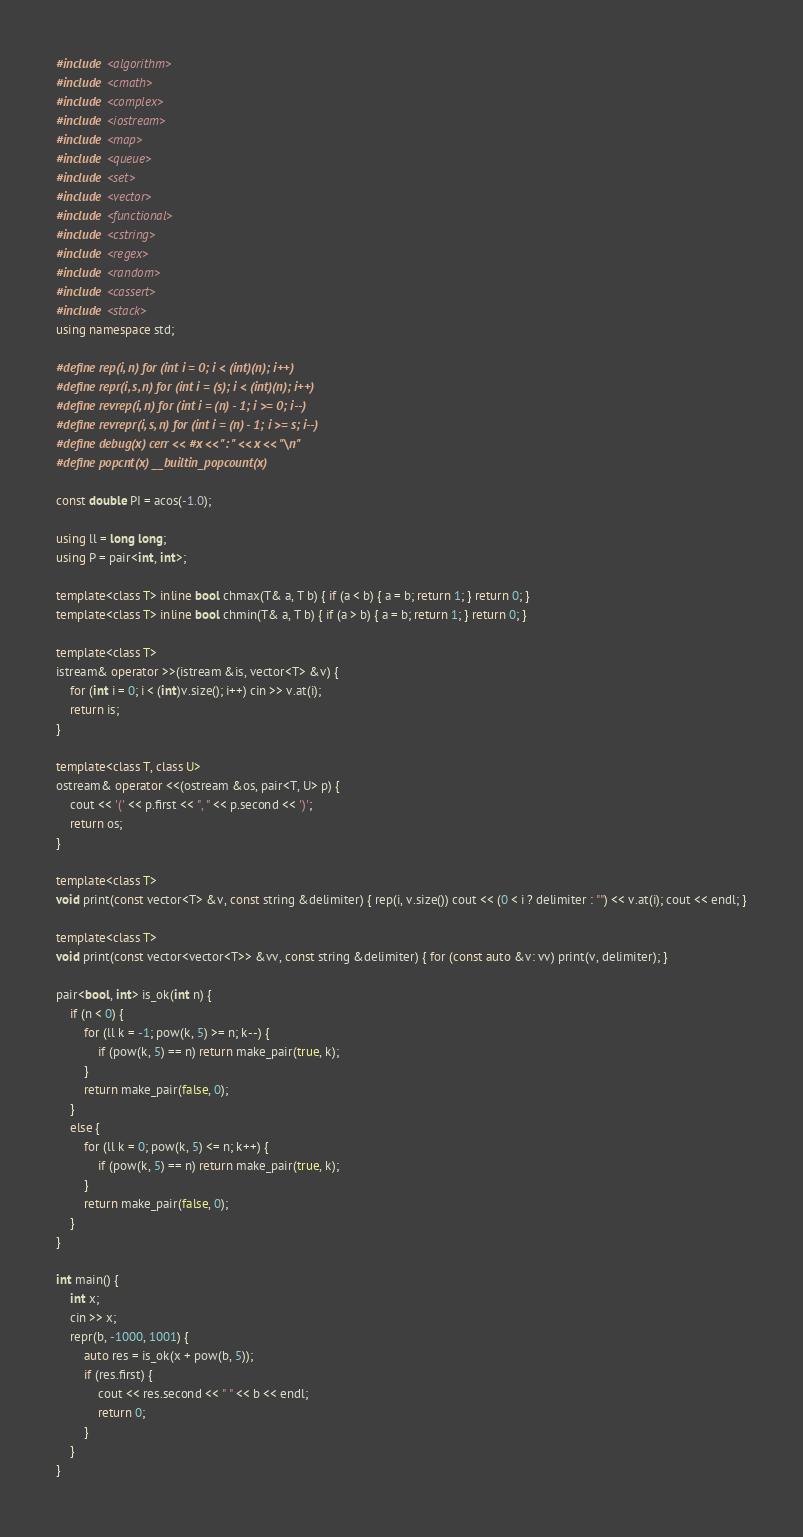<code> <loc_0><loc_0><loc_500><loc_500><_C++_>#include <algorithm>
#include <cmath>
#include <complex>
#include <iostream>
#include <map>
#include <queue>
#include <set>
#include <vector>
#include <functional>
#include <cstring>
#include <regex>
#include <random>
#include <cassert>
#include <stack>
using namespace std;

#define rep(i, n) for (int i = 0; i < (int)(n); i++)
#define repr(i, s, n) for (int i = (s); i < (int)(n); i++)
#define revrep(i, n) for (int i = (n) - 1; i >= 0; i--)
#define revrepr(i, s, n) for (int i = (n) - 1; i >= s; i--)
#define debug(x) cerr << #x << ": " << x << "\n"
#define popcnt(x) __builtin_popcount(x)

const double PI = acos(-1.0);

using ll = long long;
using P = pair<int, int>;

template<class T> inline bool chmax(T& a, T b) { if (a < b) { a = b; return 1; } return 0; }
template<class T> inline bool chmin(T& a, T b) { if (a > b) { a = b; return 1; } return 0; }

template<class T>
istream& operator >>(istream &is, vector<T> &v) {
    for (int i = 0; i < (int)v.size(); i++) cin >> v.at(i);
    return is;
}

template<class T, class U>
ostream& operator <<(ostream &os, pair<T, U> p) {
    cout << '(' << p.first << ", " << p.second << ')';
    return os;
}

template<class T>
void print(const vector<T> &v, const string &delimiter) { rep(i, v.size()) cout << (0 < i ? delimiter : "") << v.at(i); cout << endl; }

template<class T>
void print(const vector<vector<T>> &vv, const string &delimiter) { for (const auto &v: vv) print(v, delimiter); }

pair<bool, int> is_ok(int n) {
    if (n < 0) {
        for (ll k = -1; pow(k, 5) >= n; k--) {
            if (pow(k, 5) == n) return make_pair(true, k);
        }
        return make_pair(false, 0);
    }
    else {
        for (ll k = 0; pow(k, 5) <= n; k++) {
            if (pow(k, 5) == n) return make_pair(true, k);
        }
        return make_pair(false, 0);
    }
}

int main() {
    int x;
    cin >> x;
    repr(b, -1000, 1001) {
        auto res = is_ok(x + pow(b, 5));
        if (res.first) {
            cout << res.second << " " << b << endl;
            return 0;
        }
    }
}</code> 